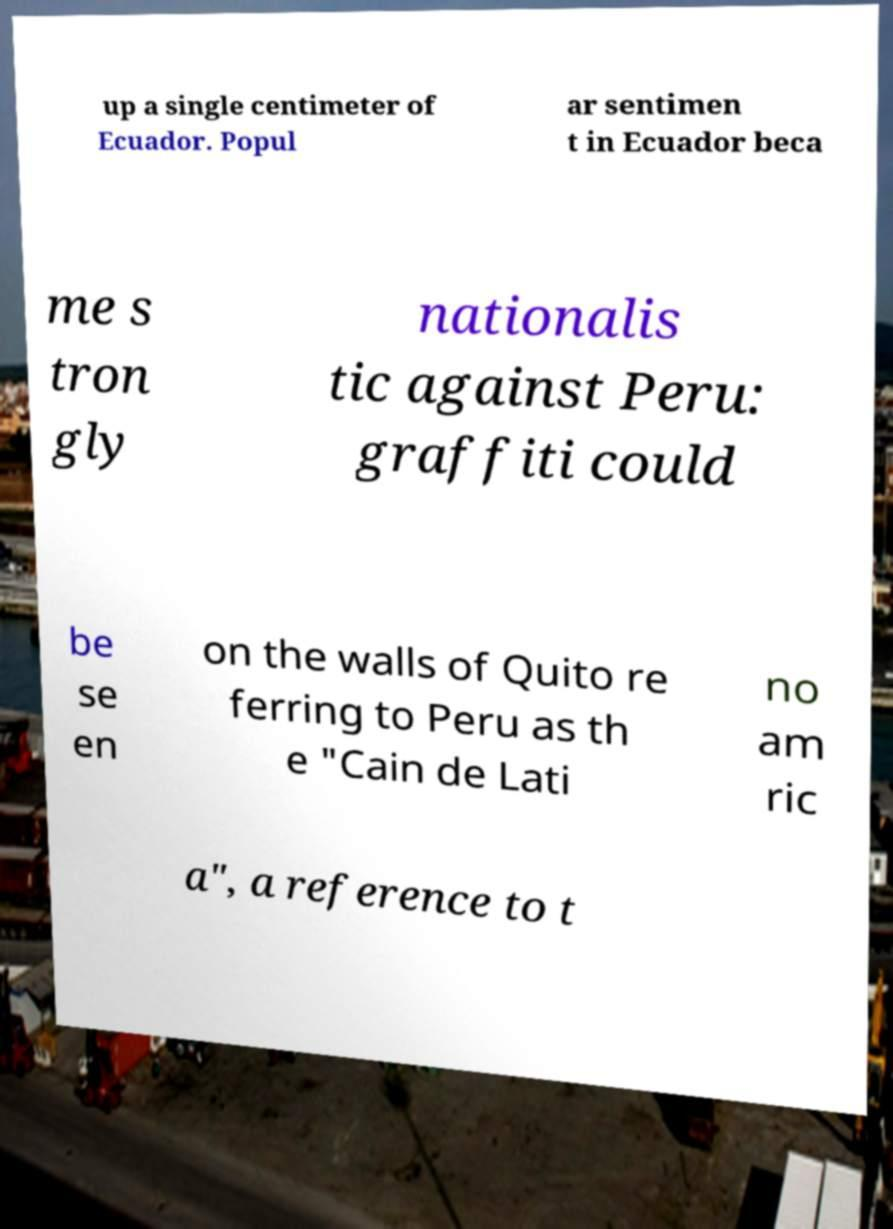For documentation purposes, I need the text within this image transcribed. Could you provide that? up a single centimeter of Ecuador. Popul ar sentimen t in Ecuador beca me s tron gly nationalis tic against Peru: graffiti could be se en on the walls of Quito re ferring to Peru as th e "Cain de Lati no am ric a", a reference to t 